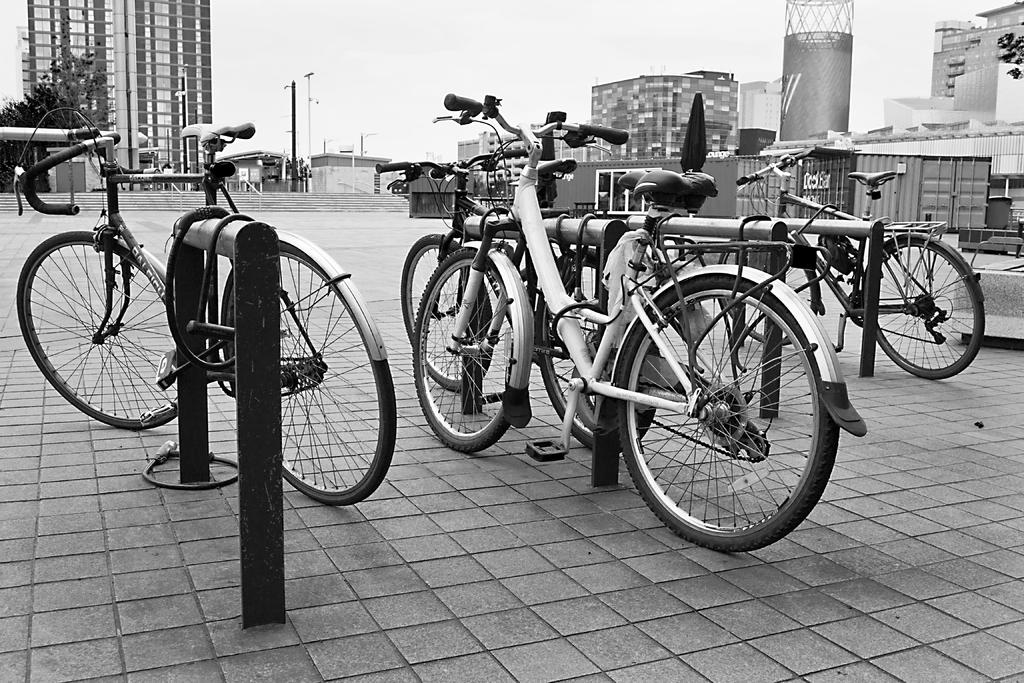What is the color scheme of the image? The image is black and white. What can be seen in the middle of the image? There are bicycles parked in the image. On what surface are the bicycles parked? The bicycles are parked on a surface. What is visible in the background of the image? There are buildings in the background of the image. Where is the stove located in the image? There is no stove present in the image. What type of vest is the person wearing in the image? There are no people or vests visible in the image. 